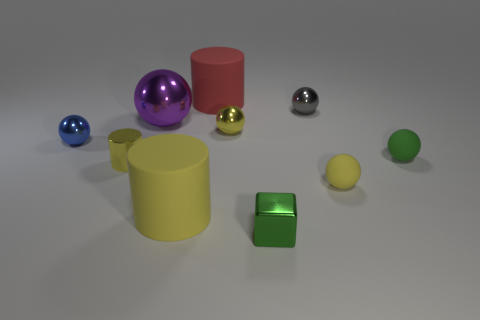The metallic cylinder is what color?
Make the answer very short. Yellow. There is a large matte cylinder in front of the tiny rubber ball behind the small yellow shiny cylinder; what color is it?
Your answer should be very brief. Yellow. There is a cube; is its color the same as the rubber ball that is behind the yellow metallic cylinder?
Offer a terse response. Yes. How many red matte cylinders are in front of the big matte object that is behind the tiny gray metal ball to the right of the large yellow rubber cylinder?
Ensure brevity in your answer.  0. There is a tiny blue shiny ball; are there any tiny yellow rubber spheres right of it?
Your answer should be compact. Yes. Is there anything else that is the same color as the large shiny sphere?
Your answer should be very brief. No. What number of spheres are small green objects or tiny yellow metal objects?
Your answer should be very brief. 2. How many yellow cylinders are behind the large yellow matte thing and to the right of the tiny shiny cylinder?
Give a very brief answer. 0. Are there the same number of large rubber cylinders behind the purple shiny thing and gray metal spheres that are right of the gray thing?
Give a very brief answer. No. Is the shape of the yellow metallic object that is to the right of the small metal cylinder the same as  the gray thing?
Ensure brevity in your answer.  Yes. 